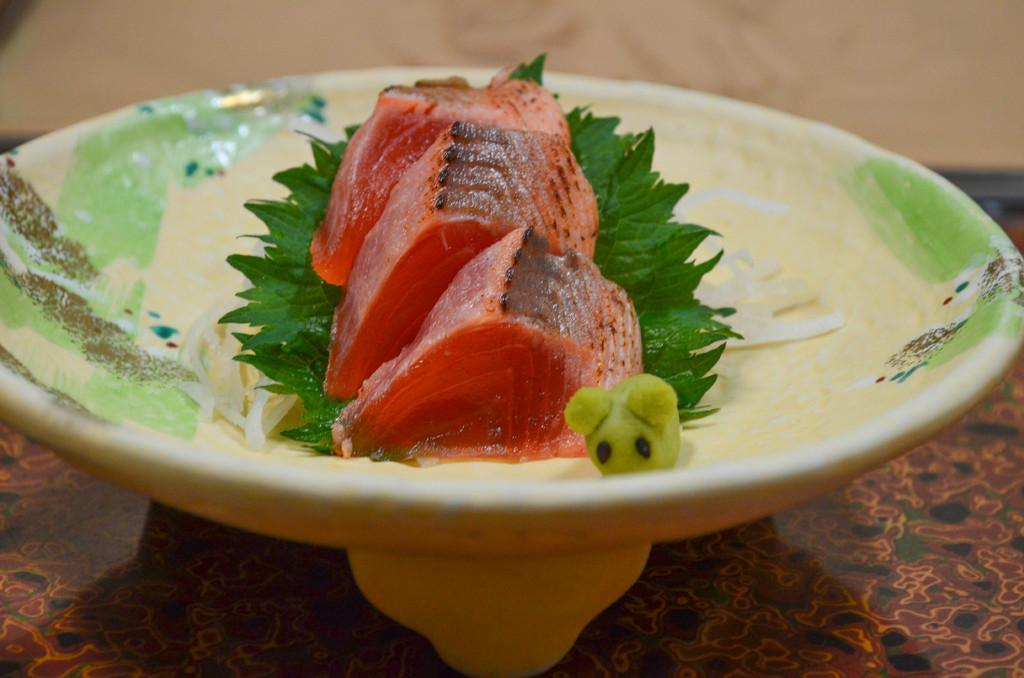What is on the plate that is visible in the image? There is a food item on a plate in the image. Where is the plate located in the image? The plate is placed on a table in the image. What type of scarecrow can be seen in the image? There is no scarecrow present in the image; it only features a food item on a plate placed on a table. 